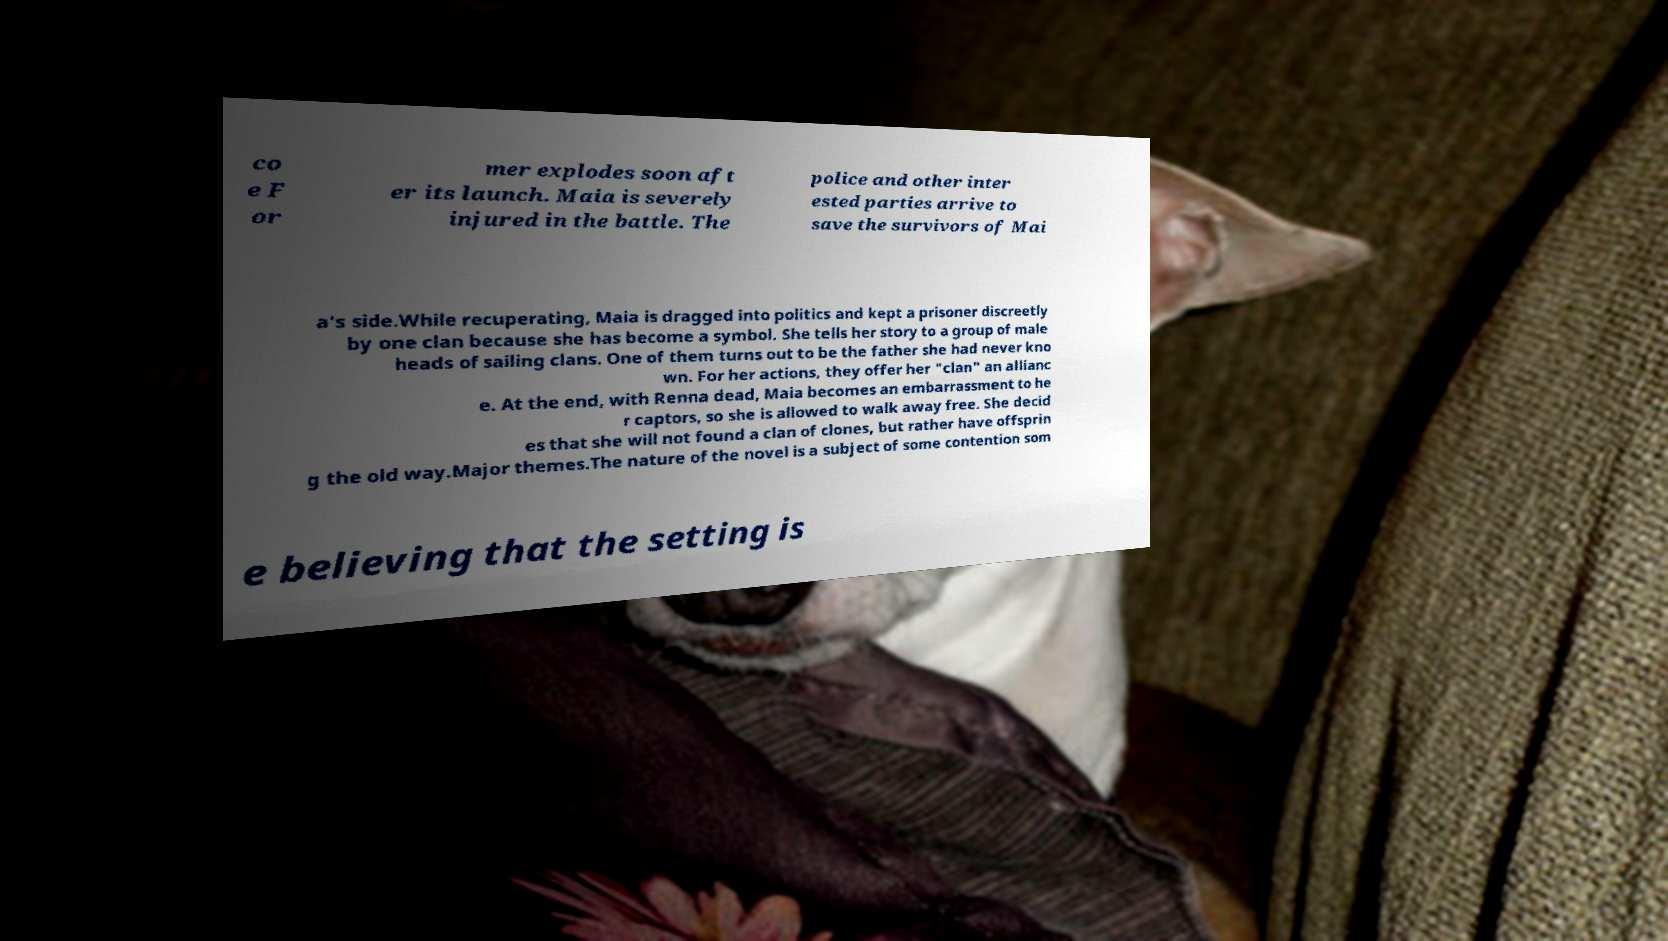For documentation purposes, I need the text within this image transcribed. Could you provide that? co e F or mer explodes soon aft er its launch. Maia is severely injured in the battle. The police and other inter ested parties arrive to save the survivors of Mai a's side.While recuperating, Maia is dragged into politics and kept a prisoner discreetly by one clan because she has become a symbol. She tells her story to a group of male heads of sailing clans. One of them turns out to be the father she had never kno wn. For her actions, they offer her "clan" an allianc e. At the end, with Renna dead, Maia becomes an embarrassment to he r captors, so she is allowed to walk away free. She decid es that she will not found a clan of clones, but rather have offsprin g the old way.Major themes.The nature of the novel is a subject of some contention som e believing that the setting is 